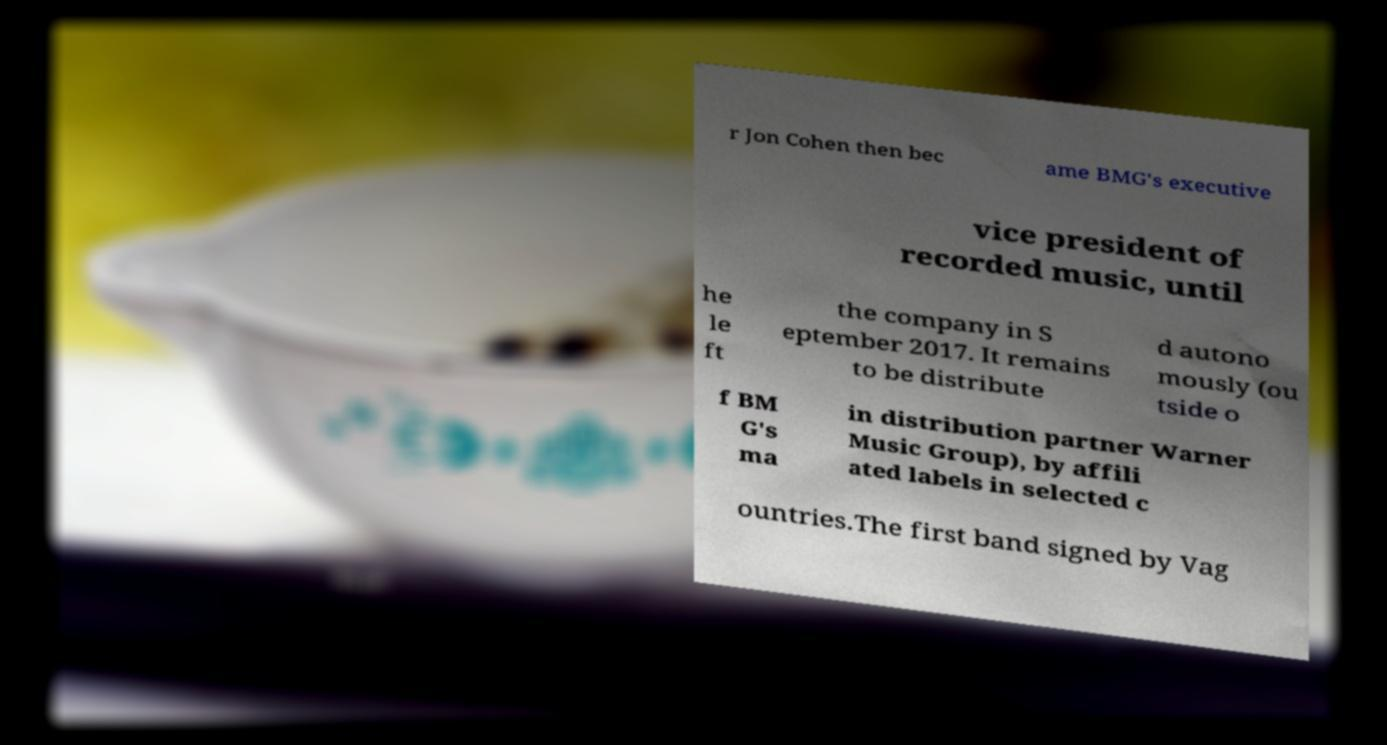Please read and relay the text visible in this image. What does it say? r Jon Cohen then bec ame BMG's executive vice president of recorded music, until he le ft the company in S eptember 2017. It remains to be distribute d autono mously (ou tside o f BM G's ma in distribution partner Warner Music Group), by affili ated labels in selected c ountries.The first band signed by Vag 